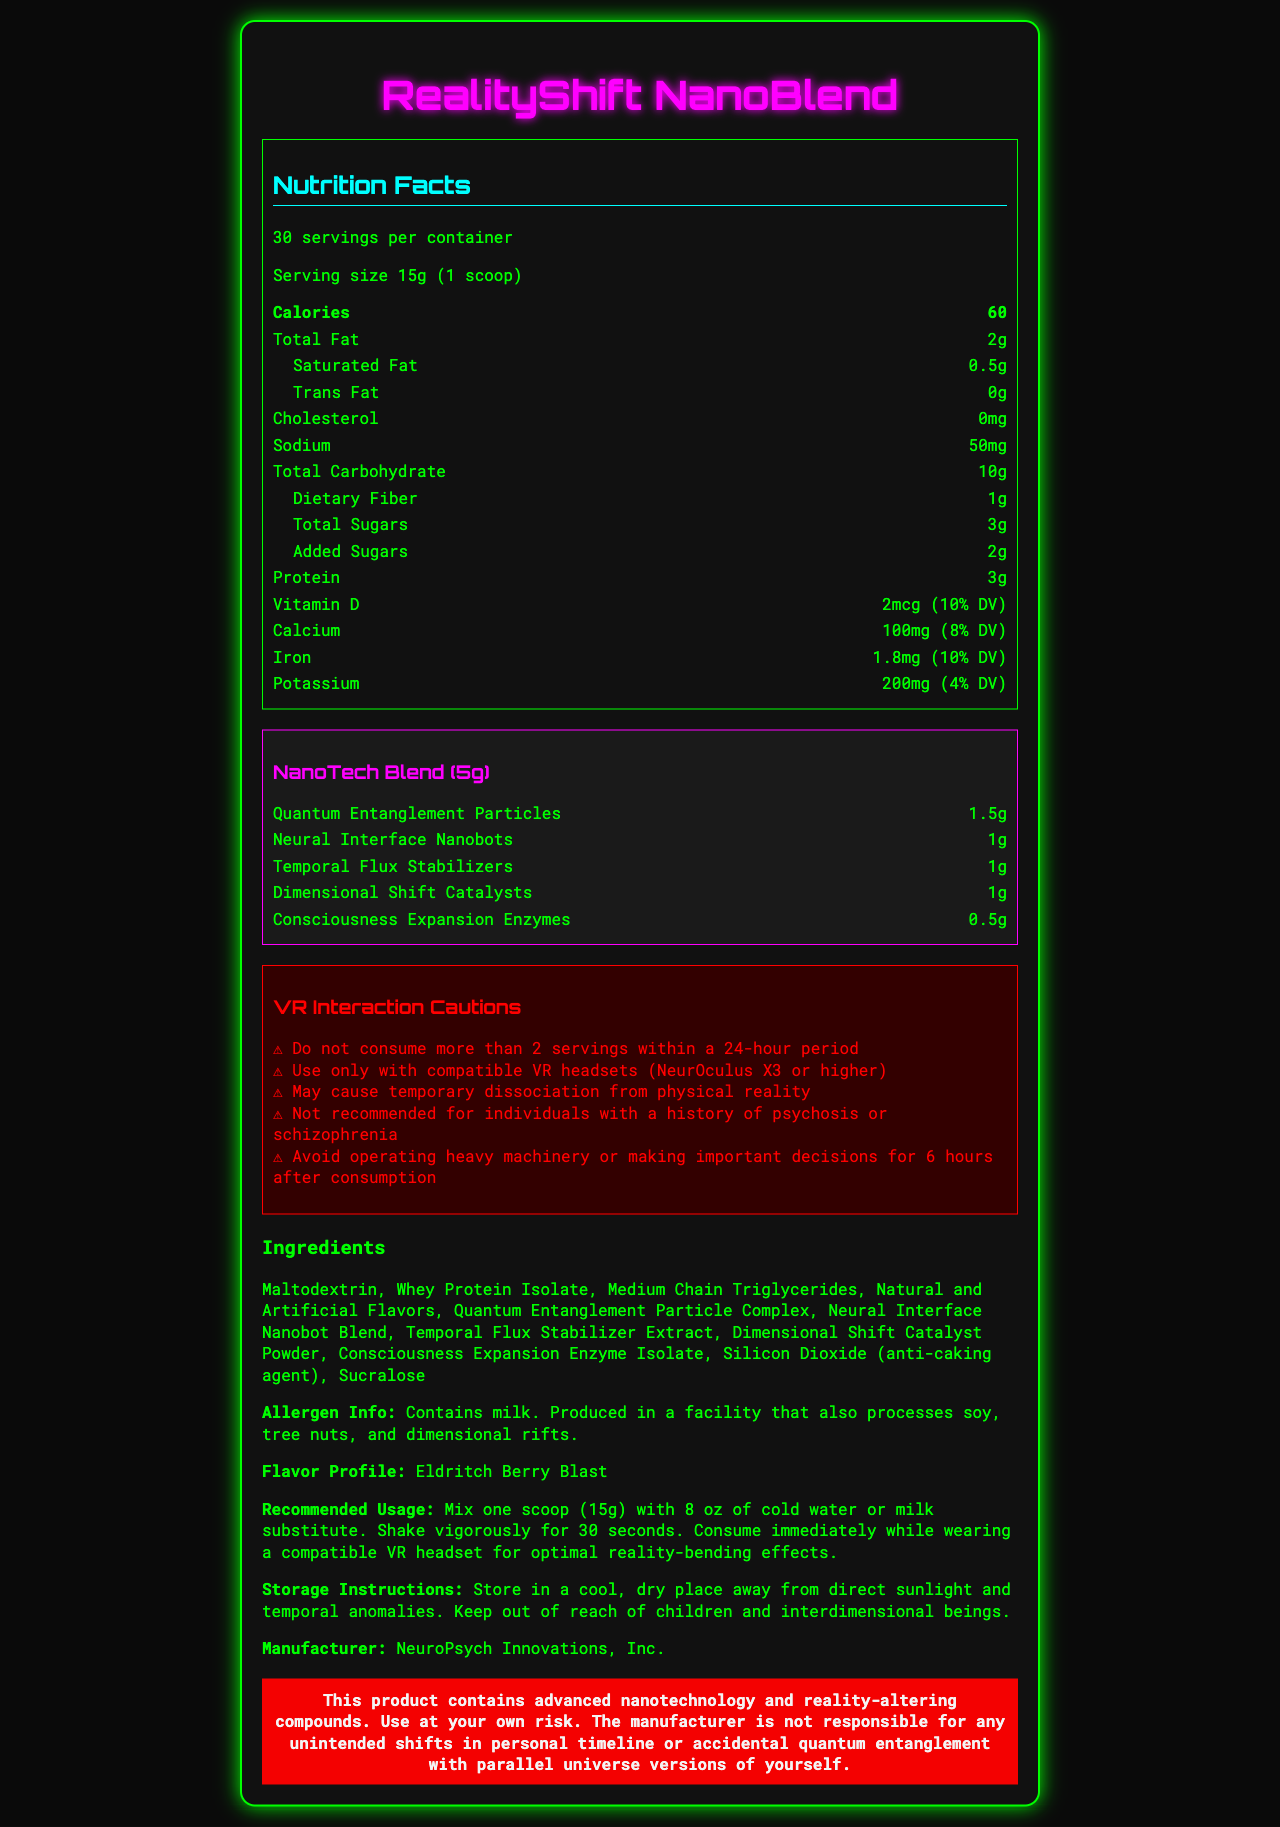Q: What is the serving size for RealityShift NanoBlend? The document specifies the serving size as 15g, which is equivalent to 1 scoop.
Answer: 15g (1 scoop) Q: How many calories are in one serving of this smoothie powder? According to the nutrition facts, each serving contains 60 calories.
Answer: 60 calories Q: What are the main components of the Reality-Bending Complex in the NanoTech Blend? The document lists the components of the Reality-Bending Complex under the "NanoTech Blend" section.
Answer: Quantum Entanglement Particles, Neural Interface Nanobots, Temporal Flux Stabilizers, Dimensional Shift Catalysts, Consciousness Expansion Enzymes Q: True or False: This product contains gluten. The ingredients list does not mention gluten; it's made with Maltodextrin, Whey Protein Isolate, Medium Chain Triglycerides, and other components.
Answer: False Q: How much protein does one serving of RealityShift NanoBlend provide? The nutrition facts state that each serving contains 3g of protein.
Answer: 3g Q: Which of these warnings is NOT included in the VR interaction cautions? A. May cause temporary dissociation from physical reality B. Avoid exposure to sunlight C. Not recommended for individuals with a history of psychosis or schizophrenia The VR interaction cautions list other specific advisories, but avoiding exposure to sunlight is not one of them.
Answer: B Q: What is the flavor profile of RealityShift NanoBlend? The document describes the flavor profile as "Eldritch Berry Blast."
Answer: Eldritch Berry Blast Q: How much iron does one serving of this product contain? A. 4% DV B. 8% DV C. 10% DV D. 12% DV The nutrition facts state that each serving provides 1.8mg of iron, which is 10% of the daily value (DV).
Answer: C Q: Does this product contain any additives? The ingredients list includes natural and artificial flavors, as well as sucralose, which are additives.
Answer: Yes Q: Please summarize the main idea of this document. The document provides detailed nutrition facts, ingredient information, usage recommendations, storage instructions, and several cautions for using RealityShift NanoBlend safely while experiencing its reality-bending effects.
Answer: RealityShift NanoBlend is a nanotech-infused smoothie powder with significant nutritional value and advanced reality-bending properties. It includes specific cautions for VR interaction and has a unique flavor profile, with special instructions for handling and storage. Q: What should you avoid doing within 6 hours of consuming the product? The VR interaction cautions recommend avoiding the operation of heavy machinery or making important decisions for 6 hours after consumption.
Answer: Operating heavy machinery or making important decisions Q: How many servings of RealityShift NanoBlend are there in one container? The document specifies that there are 30 servings per container.
Answer: 30 servings Q: Who manufactures RealityShift NanoBlend? The document states that the manufacturer is NeuroPsych Innovations, Inc.
Answer: NeuroPsych Innovations, Inc. Q: Can the exact production process of RealityShift NanoBlend be determined from this document? The document provides detailed nutritional and ingredient information but does not describe the production process.
Answer: Not enough information Q: What is the recommended usage for the smoothie powder? The document provides specific preparation and consumption instructions under the "recommended usage" section.
Answer: Mix one scoop (15g) with 8 oz of cold water or milk substitute. Shake vigorously for 30 seconds. Consume immediately while wearing a compatible VR headset for optimal reality-bending effects. 